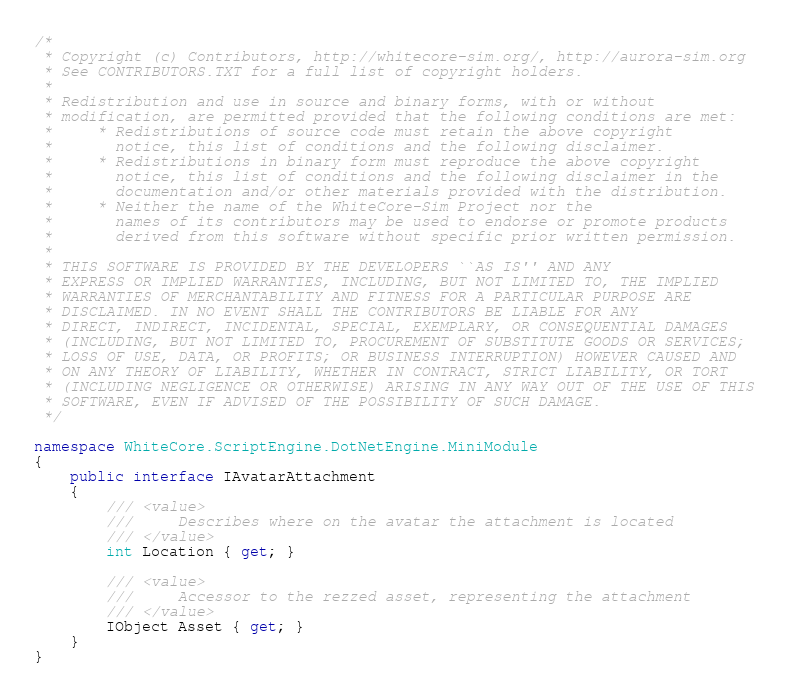Convert code to text. <code><loc_0><loc_0><loc_500><loc_500><_C#_>/*
 * Copyright (c) Contributors, http://whitecore-sim.org/, http://aurora-sim.org
 * See CONTRIBUTORS.TXT for a full list of copyright holders.
 *
 * Redistribution and use in source and binary forms, with or without
 * modification, are permitted provided that the following conditions are met:
 *     * Redistributions of source code must retain the above copyright
 *       notice, this list of conditions and the following disclaimer.
 *     * Redistributions in binary form must reproduce the above copyright
 *       notice, this list of conditions and the following disclaimer in the
 *       documentation and/or other materials provided with the distribution.
 *     * Neither the name of the WhiteCore-Sim Project nor the
 *       names of its contributors may be used to endorse or promote products
 *       derived from this software without specific prior written permission.
 *
 * THIS SOFTWARE IS PROVIDED BY THE DEVELOPERS ``AS IS'' AND ANY
 * EXPRESS OR IMPLIED WARRANTIES, INCLUDING, BUT NOT LIMITED TO, THE IMPLIED
 * WARRANTIES OF MERCHANTABILITY AND FITNESS FOR A PARTICULAR PURPOSE ARE
 * DISCLAIMED. IN NO EVENT SHALL THE CONTRIBUTORS BE LIABLE FOR ANY
 * DIRECT, INDIRECT, INCIDENTAL, SPECIAL, EXEMPLARY, OR CONSEQUENTIAL DAMAGES
 * (INCLUDING, BUT NOT LIMITED TO, PROCUREMENT OF SUBSTITUTE GOODS OR SERVICES;
 * LOSS OF USE, DATA, OR PROFITS; OR BUSINESS INTERRUPTION) HOWEVER CAUSED AND
 * ON ANY THEORY OF LIABILITY, WHETHER IN CONTRACT, STRICT LIABILITY, OR TORT
 * (INCLUDING NEGLIGENCE OR OTHERWISE) ARISING IN ANY WAY OUT OF THE USE OF THIS
 * SOFTWARE, EVEN IF ADVISED OF THE POSSIBILITY OF SUCH DAMAGE.
 */

namespace WhiteCore.ScriptEngine.DotNetEngine.MiniModule
{
    public interface IAvatarAttachment
    {
        /// <value>
        ///     Describes where on the avatar the attachment is located
        /// </value>
        int Location { get; }

        /// <value>
        ///     Accessor to the rezzed asset, representing the attachment
        /// </value>
        IObject Asset { get; }
    }
}
</code> 